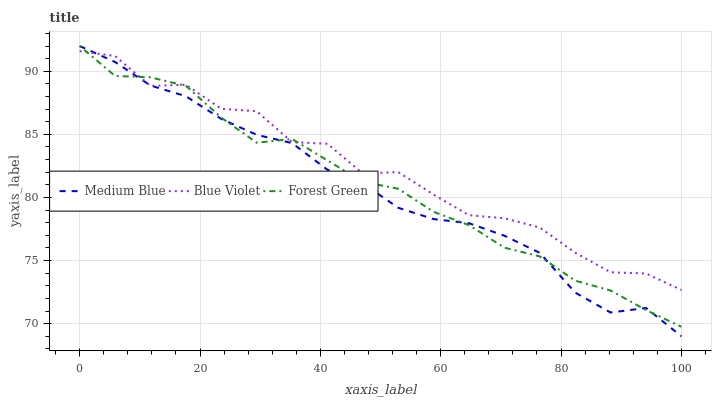Does Medium Blue have the minimum area under the curve?
Answer yes or no. Yes. Does Blue Violet have the maximum area under the curve?
Answer yes or no. Yes. Does Blue Violet have the minimum area under the curve?
Answer yes or no. No. Does Medium Blue have the maximum area under the curve?
Answer yes or no. No. Is Medium Blue the smoothest?
Answer yes or no. Yes. Is Blue Violet the roughest?
Answer yes or no. Yes. Is Blue Violet the smoothest?
Answer yes or no. No. Is Medium Blue the roughest?
Answer yes or no. No. Does Medium Blue have the lowest value?
Answer yes or no. Yes. Does Blue Violet have the lowest value?
Answer yes or no. No. Does Medium Blue have the highest value?
Answer yes or no. Yes. Does Blue Violet have the highest value?
Answer yes or no. No. Does Blue Violet intersect Forest Green?
Answer yes or no. Yes. Is Blue Violet less than Forest Green?
Answer yes or no. No. Is Blue Violet greater than Forest Green?
Answer yes or no. No. 